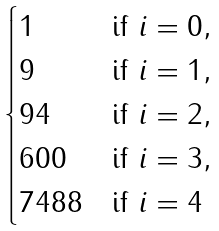<formula> <loc_0><loc_0><loc_500><loc_500>\begin{cases} 1 & \text {if } i = 0 , \\ 9 & \text {if  } i = 1 , \\ 9 4 & \text {if  } i = 2 , \\ 6 0 0 & \text {if  } i = 3 , \\ 7 4 8 8 & \text {if  } i = 4 \end{cases}</formula> 